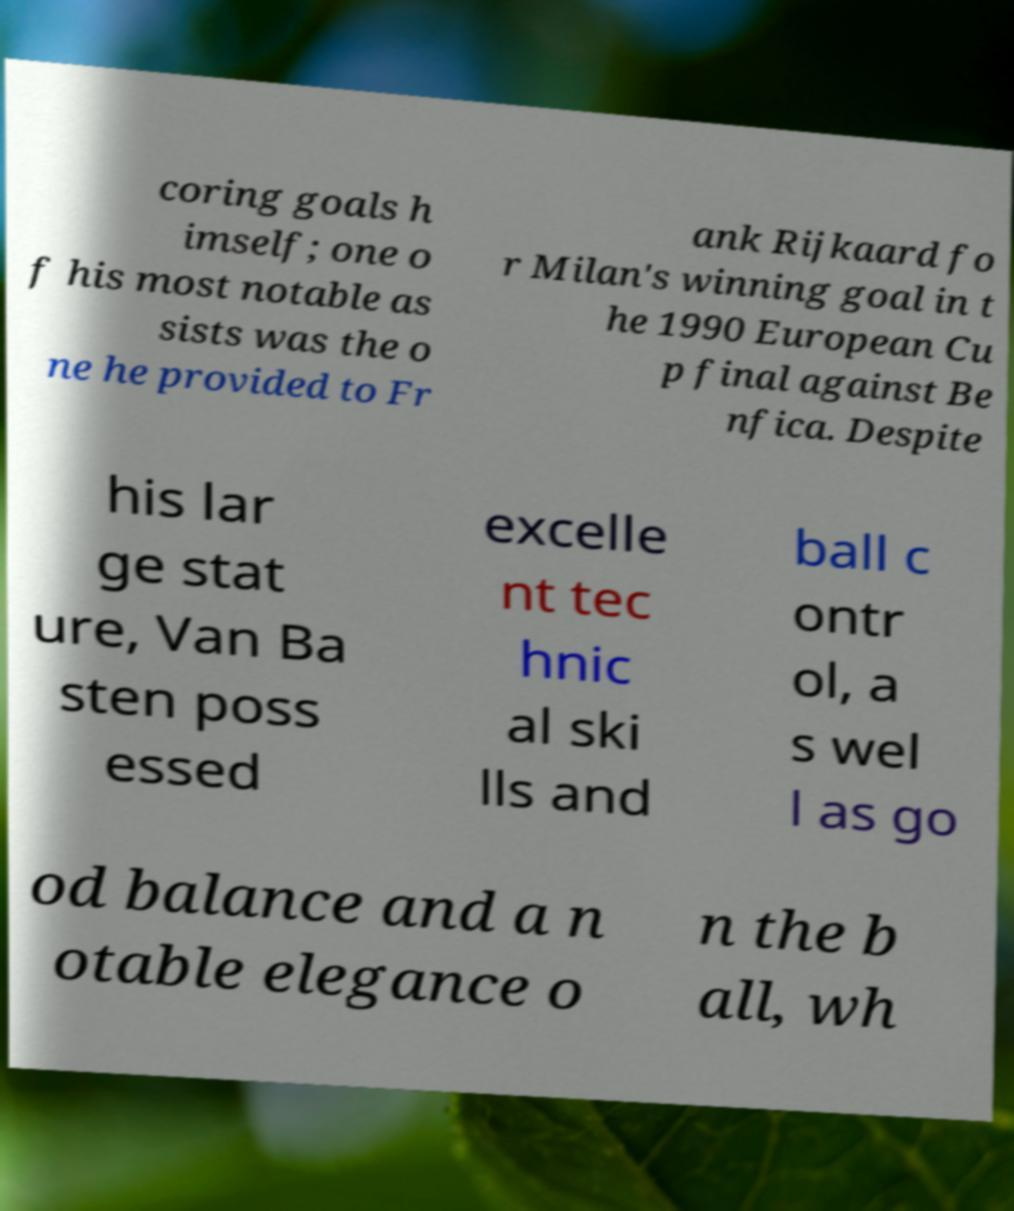What messages or text are displayed in this image? I need them in a readable, typed format. coring goals h imself; one o f his most notable as sists was the o ne he provided to Fr ank Rijkaard fo r Milan's winning goal in t he 1990 European Cu p final against Be nfica. Despite his lar ge stat ure, Van Ba sten poss essed excelle nt tec hnic al ski lls and ball c ontr ol, a s wel l as go od balance and a n otable elegance o n the b all, wh 